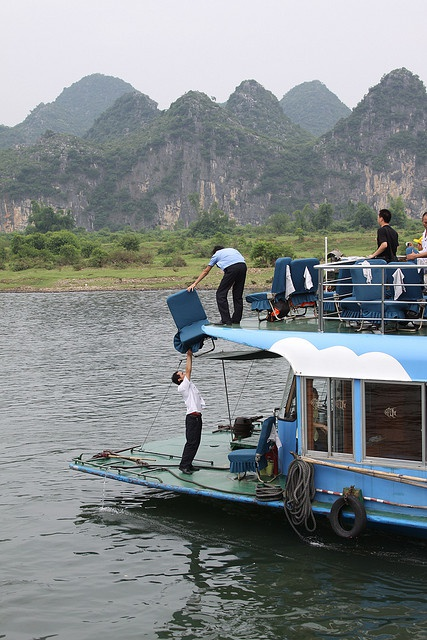Describe the objects in this image and their specific colors. I can see boat in white, black, darkgray, and gray tones, people in white, black, lavender, darkgray, and gray tones, people in white, black, lavender, and darkgray tones, chair in white, darkblue, black, and gray tones, and chair in white, black, blue, darkblue, and darkgray tones in this image. 